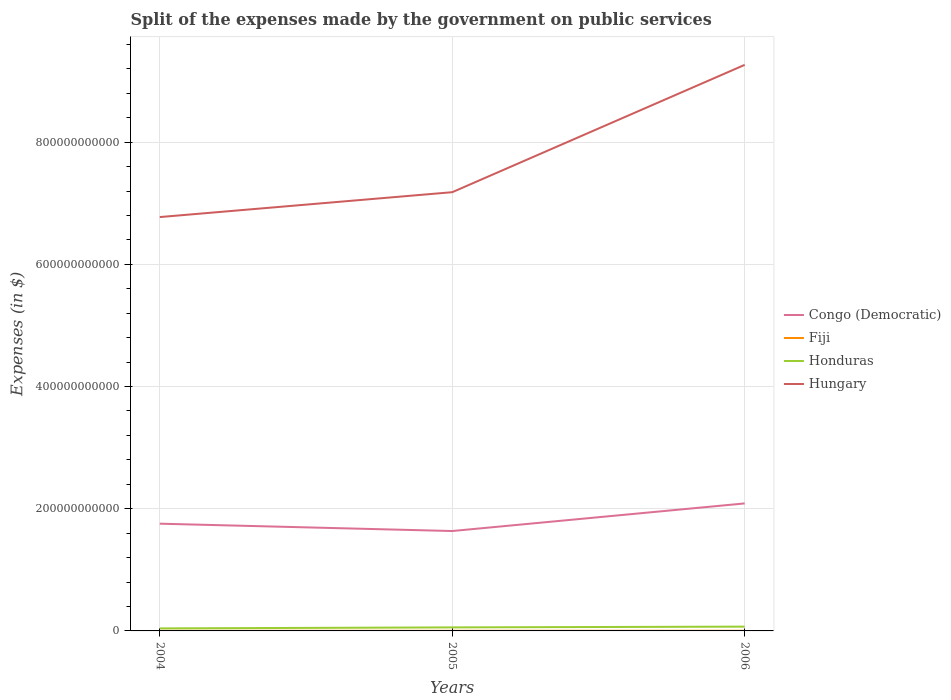How many different coloured lines are there?
Offer a very short reply. 4. Does the line corresponding to Honduras intersect with the line corresponding to Hungary?
Offer a very short reply. No. Is the number of lines equal to the number of legend labels?
Your answer should be very brief. Yes. Across all years, what is the maximum expenses made by the government on public services in Honduras?
Ensure brevity in your answer.  4.13e+09. What is the total expenses made by the government on public services in Fiji in the graph?
Your answer should be compact. -5.15e+07. What is the difference between the highest and the second highest expenses made by the government on public services in Honduras?
Give a very brief answer. 2.91e+09. Is the expenses made by the government on public services in Congo (Democratic) strictly greater than the expenses made by the government on public services in Fiji over the years?
Ensure brevity in your answer.  No. How many lines are there?
Give a very brief answer. 4. How many years are there in the graph?
Your response must be concise. 3. What is the difference between two consecutive major ticks on the Y-axis?
Your response must be concise. 2.00e+11. Are the values on the major ticks of Y-axis written in scientific E-notation?
Ensure brevity in your answer.  No. Does the graph contain grids?
Offer a very short reply. Yes. What is the title of the graph?
Your answer should be very brief. Split of the expenses made by the government on public services. Does "World" appear as one of the legend labels in the graph?
Your response must be concise. No. What is the label or title of the Y-axis?
Provide a succinct answer. Expenses (in $). What is the Expenses (in $) in Congo (Democratic) in 2004?
Ensure brevity in your answer.  1.76e+11. What is the Expenses (in $) in Fiji in 2004?
Provide a succinct answer. 1.83e+08. What is the Expenses (in $) in Honduras in 2004?
Provide a short and direct response. 4.13e+09. What is the Expenses (in $) in Hungary in 2004?
Offer a very short reply. 6.77e+11. What is the Expenses (in $) of Congo (Democratic) in 2005?
Offer a very short reply. 1.64e+11. What is the Expenses (in $) in Fiji in 2005?
Provide a succinct answer. 2.01e+08. What is the Expenses (in $) in Honduras in 2005?
Your response must be concise. 5.77e+09. What is the Expenses (in $) in Hungary in 2005?
Keep it short and to the point. 7.18e+11. What is the Expenses (in $) in Congo (Democratic) in 2006?
Your answer should be compact. 2.09e+11. What is the Expenses (in $) in Fiji in 2006?
Provide a succinct answer. 2.34e+08. What is the Expenses (in $) in Honduras in 2006?
Your answer should be very brief. 7.04e+09. What is the Expenses (in $) in Hungary in 2006?
Provide a succinct answer. 9.26e+11. Across all years, what is the maximum Expenses (in $) of Congo (Democratic)?
Make the answer very short. 2.09e+11. Across all years, what is the maximum Expenses (in $) of Fiji?
Your response must be concise. 2.34e+08. Across all years, what is the maximum Expenses (in $) in Honduras?
Your answer should be compact. 7.04e+09. Across all years, what is the maximum Expenses (in $) of Hungary?
Make the answer very short. 9.26e+11. Across all years, what is the minimum Expenses (in $) in Congo (Democratic)?
Offer a very short reply. 1.64e+11. Across all years, what is the minimum Expenses (in $) in Fiji?
Ensure brevity in your answer.  1.83e+08. Across all years, what is the minimum Expenses (in $) of Honduras?
Your answer should be compact. 4.13e+09. Across all years, what is the minimum Expenses (in $) in Hungary?
Ensure brevity in your answer.  6.77e+11. What is the total Expenses (in $) of Congo (Democratic) in the graph?
Keep it short and to the point. 5.48e+11. What is the total Expenses (in $) in Fiji in the graph?
Offer a very short reply. 6.18e+08. What is the total Expenses (in $) of Honduras in the graph?
Keep it short and to the point. 1.69e+1. What is the total Expenses (in $) of Hungary in the graph?
Your response must be concise. 2.32e+12. What is the difference between the Expenses (in $) of Congo (Democratic) in 2004 and that in 2005?
Give a very brief answer. 1.20e+1. What is the difference between the Expenses (in $) in Fiji in 2004 and that in 2005?
Give a very brief answer. -1.80e+07. What is the difference between the Expenses (in $) in Honduras in 2004 and that in 2005?
Keep it short and to the point. -1.64e+09. What is the difference between the Expenses (in $) of Hungary in 2004 and that in 2005?
Your answer should be compact. -4.07e+1. What is the difference between the Expenses (in $) of Congo (Democratic) in 2004 and that in 2006?
Offer a terse response. -3.32e+1. What is the difference between the Expenses (in $) of Fiji in 2004 and that in 2006?
Ensure brevity in your answer.  -5.15e+07. What is the difference between the Expenses (in $) in Honduras in 2004 and that in 2006?
Keep it short and to the point. -2.91e+09. What is the difference between the Expenses (in $) in Hungary in 2004 and that in 2006?
Offer a very short reply. -2.49e+11. What is the difference between the Expenses (in $) in Congo (Democratic) in 2005 and that in 2006?
Your response must be concise. -4.52e+1. What is the difference between the Expenses (in $) of Fiji in 2005 and that in 2006?
Provide a short and direct response. -3.34e+07. What is the difference between the Expenses (in $) of Honduras in 2005 and that in 2006?
Provide a succinct answer. -1.27e+09. What is the difference between the Expenses (in $) in Hungary in 2005 and that in 2006?
Your response must be concise. -2.08e+11. What is the difference between the Expenses (in $) of Congo (Democratic) in 2004 and the Expenses (in $) of Fiji in 2005?
Ensure brevity in your answer.  1.75e+11. What is the difference between the Expenses (in $) of Congo (Democratic) in 2004 and the Expenses (in $) of Honduras in 2005?
Your response must be concise. 1.70e+11. What is the difference between the Expenses (in $) in Congo (Democratic) in 2004 and the Expenses (in $) in Hungary in 2005?
Make the answer very short. -5.43e+11. What is the difference between the Expenses (in $) of Fiji in 2004 and the Expenses (in $) of Honduras in 2005?
Ensure brevity in your answer.  -5.59e+09. What is the difference between the Expenses (in $) in Fiji in 2004 and the Expenses (in $) in Hungary in 2005?
Ensure brevity in your answer.  -7.18e+11. What is the difference between the Expenses (in $) in Honduras in 2004 and the Expenses (in $) in Hungary in 2005?
Make the answer very short. -7.14e+11. What is the difference between the Expenses (in $) of Congo (Democratic) in 2004 and the Expenses (in $) of Fiji in 2006?
Offer a very short reply. 1.75e+11. What is the difference between the Expenses (in $) in Congo (Democratic) in 2004 and the Expenses (in $) in Honduras in 2006?
Your answer should be compact. 1.68e+11. What is the difference between the Expenses (in $) of Congo (Democratic) in 2004 and the Expenses (in $) of Hungary in 2006?
Offer a terse response. -7.51e+11. What is the difference between the Expenses (in $) in Fiji in 2004 and the Expenses (in $) in Honduras in 2006?
Provide a succinct answer. -6.86e+09. What is the difference between the Expenses (in $) in Fiji in 2004 and the Expenses (in $) in Hungary in 2006?
Provide a short and direct response. -9.26e+11. What is the difference between the Expenses (in $) in Honduras in 2004 and the Expenses (in $) in Hungary in 2006?
Your response must be concise. -9.22e+11. What is the difference between the Expenses (in $) in Congo (Democratic) in 2005 and the Expenses (in $) in Fiji in 2006?
Ensure brevity in your answer.  1.63e+11. What is the difference between the Expenses (in $) in Congo (Democratic) in 2005 and the Expenses (in $) in Honduras in 2006?
Offer a terse response. 1.56e+11. What is the difference between the Expenses (in $) in Congo (Democratic) in 2005 and the Expenses (in $) in Hungary in 2006?
Provide a succinct answer. -7.63e+11. What is the difference between the Expenses (in $) in Fiji in 2005 and the Expenses (in $) in Honduras in 2006?
Give a very brief answer. -6.84e+09. What is the difference between the Expenses (in $) in Fiji in 2005 and the Expenses (in $) in Hungary in 2006?
Ensure brevity in your answer.  -9.26e+11. What is the difference between the Expenses (in $) of Honduras in 2005 and the Expenses (in $) of Hungary in 2006?
Keep it short and to the point. -9.21e+11. What is the average Expenses (in $) of Congo (Democratic) per year?
Give a very brief answer. 1.83e+11. What is the average Expenses (in $) in Fiji per year?
Offer a terse response. 2.06e+08. What is the average Expenses (in $) of Honduras per year?
Ensure brevity in your answer.  5.65e+09. What is the average Expenses (in $) in Hungary per year?
Provide a short and direct response. 7.74e+11. In the year 2004, what is the difference between the Expenses (in $) in Congo (Democratic) and Expenses (in $) in Fiji?
Give a very brief answer. 1.75e+11. In the year 2004, what is the difference between the Expenses (in $) of Congo (Democratic) and Expenses (in $) of Honduras?
Make the answer very short. 1.71e+11. In the year 2004, what is the difference between the Expenses (in $) in Congo (Democratic) and Expenses (in $) in Hungary?
Keep it short and to the point. -5.02e+11. In the year 2004, what is the difference between the Expenses (in $) in Fiji and Expenses (in $) in Honduras?
Provide a short and direct response. -3.95e+09. In the year 2004, what is the difference between the Expenses (in $) of Fiji and Expenses (in $) of Hungary?
Offer a terse response. -6.77e+11. In the year 2004, what is the difference between the Expenses (in $) of Honduras and Expenses (in $) of Hungary?
Ensure brevity in your answer.  -6.73e+11. In the year 2005, what is the difference between the Expenses (in $) of Congo (Democratic) and Expenses (in $) of Fiji?
Make the answer very short. 1.63e+11. In the year 2005, what is the difference between the Expenses (in $) of Congo (Democratic) and Expenses (in $) of Honduras?
Provide a short and direct response. 1.58e+11. In the year 2005, what is the difference between the Expenses (in $) of Congo (Democratic) and Expenses (in $) of Hungary?
Offer a very short reply. -5.55e+11. In the year 2005, what is the difference between the Expenses (in $) of Fiji and Expenses (in $) of Honduras?
Your answer should be very brief. -5.57e+09. In the year 2005, what is the difference between the Expenses (in $) in Fiji and Expenses (in $) in Hungary?
Ensure brevity in your answer.  -7.18e+11. In the year 2005, what is the difference between the Expenses (in $) of Honduras and Expenses (in $) of Hungary?
Provide a succinct answer. -7.12e+11. In the year 2006, what is the difference between the Expenses (in $) of Congo (Democratic) and Expenses (in $) of Fiji?
Give a very brief answer. 2.08e+11. In the year 2006, what is the difference between the Expenses (in $) of Congo (Democratic) and Expenses (in $) of Honduras?
Offer a terse response. 2.02e+11. In the year 2006, what is the difference between the Expenses (in $) in Congo (Democratic) and Expenses (in $) in Hungary?
Your answer should be very brief. -7.18e+11. In the year 2006, what is the difference between the Expenses (in $) of Fiji and Expenses (in $) of Honduras?
Provide a succinct answer. -6.81e+09. In the year 2006, what is the difference between the Expenses (in $) in Fiji and Expenses (in $) in Hungary?
Offer a very short reply. -9.26e+11. In the year 2006, what is the difference between the Expenses (in $) in Honduras and Expenses (in $) in Hungary?
Your response must be concise. -9.19e+11. What is the ratio of the Expenses (in $) in Congo (Democratic) in 2004 to that in 2005?
Your answer should be very brief. 1.07. What is the ratio of the Expenses (in $) of Fiji in 2004 to that in 2005?
Make the answer very short. 0.91. What is the ratio of the Expenses (in $) of Honduras in 2004 to that in 2005?
Your answer should be compact. 0.72. What is the ratio of the Expenses (in $) of Hungary in 2004 to that in 2005?
Your response must be concise. 0.94. What is the ratio of the Expenses (in $) of Congo (Democratic) in 2004 to that in 2006?
Ensure brevity in your answer.  0.84. What is the ratio of the Expenses (in $) in Fiji in 2004 to that in 2006?
Your answer should be very brief. 0.78. What is the ratio of the Expenses (in $) in Honduras in 2004 to that in 2006?
Keep it short and to the point. 0.59. What is the ratio of the Expenses (in $) in Hungary in 2004 to that in 2006?
Ensure brevity in your answer.  0.73. What is the ratio of the Expenses (in $) of Congo (Democratic) in 2005 to that in 2006?
Ensure brevity in your answer.  0.78. What is the ratio of the Expenses (in $) of Fiji in 2005 to that in 2006?
Your response must be concise. 0.86. What is the ratio of the Expenses (in $) of Honduras in 2005 to that in 2006?
Your answer should be compact. 0.82. What is the ratio of the Expenses (in $) of Hungary in 2005 to that in 2006?
Your answer should be very brief. 0.78. What is the difference between the highest and the second highest Expenses (in $) of Congo (Democratic)?
Provide a succinct answer. 3.32e+1. What is the difference between the highest and the second highest Expenses (in $) of Fiji?
Your answer should be compact. 3.34e+07. What is the difference between the highest and the second highest Expenses (in $) of Honduras?
Provide a short and direct response. 1.27e+09. What is the difference between the highest and the second highest Expenses (in $) in Hungary?
Offer a very short reply. 2.08e+11. What is the difference between the highest and the lowest Expenses (in $) in Congo (Democratic)?
Ensure brevity in your answer.  4.52e+1. What is the difference between the highest and the lowest Expenses (in $) in Fiji?
Offer a very short reply. 5.15e+07. What is the difference between the highest and the lowest Expenses (in $) in Honduras?
Keep it short and to the point. 2.91e+09. What is the difference between the highest and the lowest Expenses (in $) in Hungary?
Your answer should be very brief. 2.49e+11. 